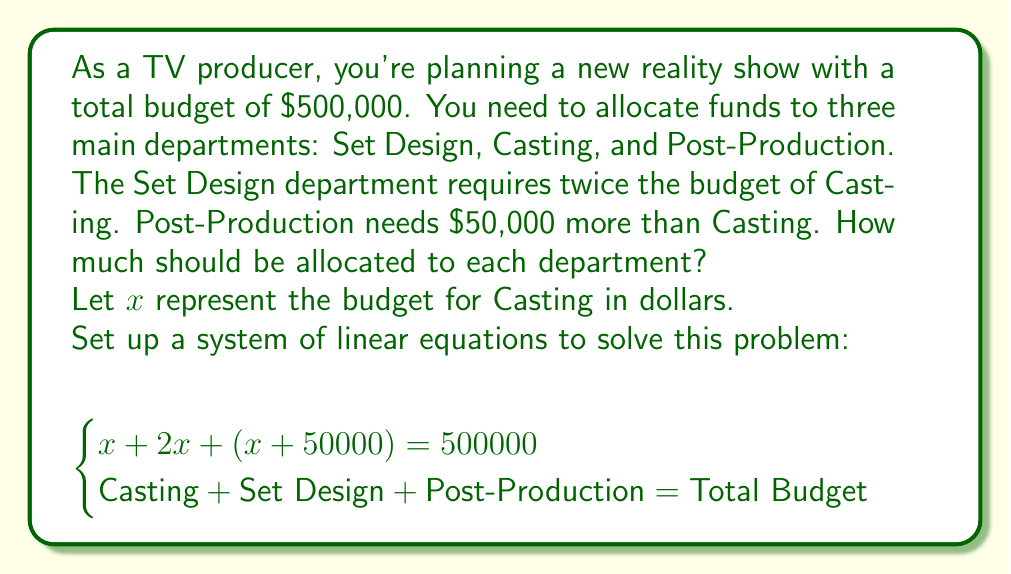What is the answer to this math problem? Let's solve this step-by-step:

1) We have the equation: $x + 2x + (x + 50000) = 500000$

2) Simplify the left side of the equation:
   $4x + 50000 = 500000$

3) Subtract 50000 from both sides:
   $4x = 450000$

4) Divide both sides by 4:
   $x = 112500$

5) Now that we know $x$ (Casting budget), we can calculate the other departments:

   Set Design: $2x = 2(112500) = 225000$
   Post-Production: $x + 50000 = 112500 + 50000 = 162500$

6) Verify the total:
   $112500 + 225000 + 162500 = 500000$

Therefore, the budget allocation is:
Casting: $112,500
Set Design: $225,000
Post-Production: $162,500
Answer: Casting: $112,500; Set Design: $225,000; Post-Production: $162,500 